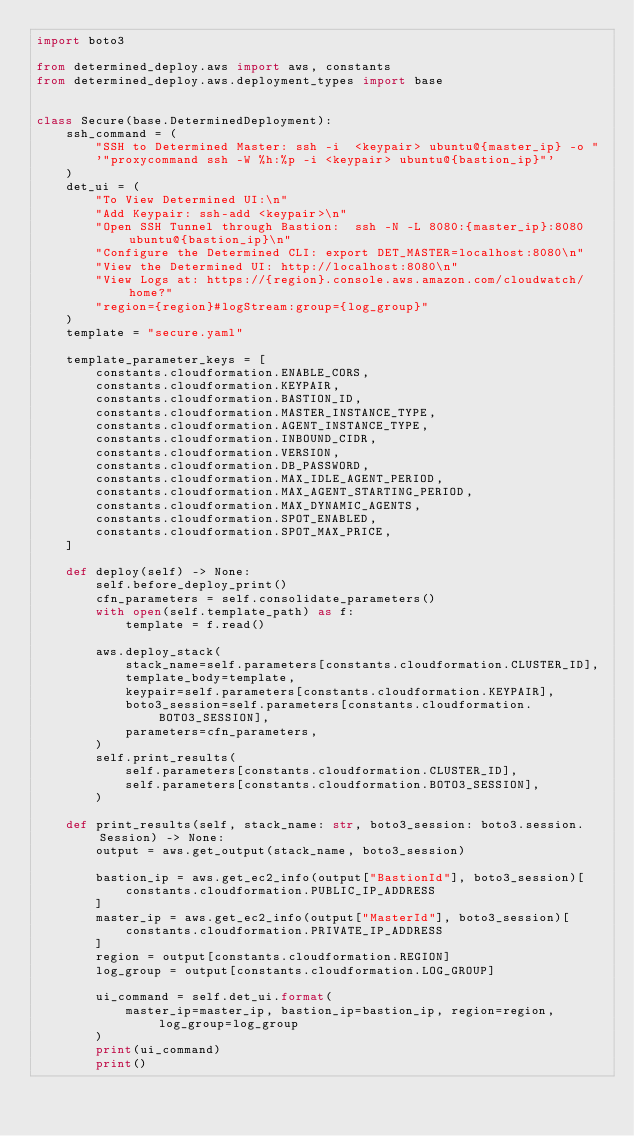Convert code to text. <code><loc_0><loc_0><loc_500><loc_500><_Python_>import boto3

from determined_deploy.aws import aws, constants
from determined_deploy.aws.deployment_types import base


class Secure(base.DeterminedDeployment):
    ssh_command = (
        "SSH to Determined Master: ssh -i  <keypair> ubuntu@{master_ip} -o "
        '"proxycommand ssh -W %h:%p -i <keypair> ubuntu@{bastion_ip}"'
    )
    det_ui = (
        "To View Determined UI:\n"
        "Add Keypair: ssh-add <keypair>\n"
        "Open SSH Tunnel through Bastion:  ssh -N -L 8080:{master_ip}:8080 ubuntu@{bastion_ip}\n"
        "Configure the Determined CLI: export DET_MASTER=localhost:8080\n"
        "View the Determined UI: http://localhost:8080\n"
        "View Logs at: https://{region}.console.aws.amazon.com/cloudwatch/home?"
        "region={region}#logStream:group={log_group}"
    )
    template = "secure.yaml"

    template_parameter_keys = [
        constants.cloudformation.ENABLE_CORS,
        constants.cloudformation.KEYPAIR,
        constants.cloudformation.BASTION_ID,
        constants.cloudformation.MASTER_INSTANCE_TYPE,
        constants.cloudformation.AGENT_INSTANCE_TYPE,
        constants.cloudformation.INBOUND_CIDR,
        constants.cloudformation.VERSION,
        constants.cloudformation.DB_PASSWORD,
        constants.cloudformation.MAX_IDLE_AGENT_PERIOD,
        constants.cloudformation.MAX_AGENT_STARTING_PERIOD,
        constants.cloudformation.MAX_DYNAMIC_AGENTS,
        constants.cloudformation.SPOT_ENABLED,
        constants.cloudformation.SPOT_MAX_PRICE,
    ]

    def deploy(self) -> None:
        self.before_deploy_print()
        cfn_parameters = self.consolidate_parameters()
        with open(self.template_path) as f:
            template = f.read()

        aws.deploy_stack(
            stack_name=self.parameters[constants.cloudformation.CLUSTER_ID],
            template_body=template,
            keypair=self.parameters[constants.cloudformation.KEYPAIR],
            boto3_session=self.parameters[constants.cloudformation.BOTO3_SESSION],
            parameters=cfn_parameters,
        )
        self.print_results(
            self.parameters[constants.cloudformation.CLUSTER_ID],
            self.parameters[constants.cloudformation.BOTO3_SESSION],
        )

    def print_results(self, stack_name: str, boto3_session: boto3.session.Session) -> None:
        output = aws.get_output(stack_name, boto3_session)

        bastion_ip = aws.get_ec2_info(output["BastionId"], boto3_session)[
            constants.cloudformation.PUBLIC_IP_ADDRESS
        ]
        master_ip = aws.get_ec2_info(output["MasterId"], boto3_session)[
            constants.cloudformation.PRIVATE_IP_ADDRESS
        ]
        region = output[constants.cloudformation.REGION]
        log_group = output[constants.cloudformation.LOG_GROUP]

        ui_command = self.det_ui.format(
            master_ip=master_ip, bastion_ip=bastion_ip, region=region, log_group=log_group
        )
        print(ui_command)
        print()
</code> 